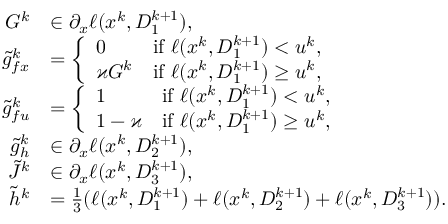<formula> <loc_0><loc_0><loc_500><loc_500>\begin{array} { r l } { G ^ { k } } & { \in \partial _ { x } \ell ( x ^ { k } , D _ { 1 } ^ { k + 1 } ) , } \\ { \tilde { g } _ { f x } ^ { k } } & { = \left \{ \begin{array} { l l } { 0 } & { i f \ell ( x ^ { k } , D _ { 1 } ^ { k + 1 } ) < u ^ { k } , } \\ { \varkappa G ^ { k } } & { i f \ell ( x ^ { k } , D _ { 1 } ^ { k + 1 } ) \geq u ^ { k } , } \end{array} } \\ { \tilde { g } _ { f u } ^ { k } } & { = \left \{ \begin{array} { l l } { 1 } & { i f \ell ( x ^ { k } , D _ { 1 } ^ { k + 1 } ) < u ^ { k } , } \\ { 1 - \varkappa } & { i f \ell ( x ^ { k } , D _ { 1 } ^ { k + 1 } ) \geq u ^ { k } , } \end{array} } \\ { \tilde { g } _ { h } ^ { k } } & { \in \partial _ { x } \ell ( x ^ { k } , D _ { 2 } ^ { k + 1 } ) , } \\ { \tilde { J } ^ { k } } & { \in \partial _ { x } \ell ( x ^ { k } , D _ { 3 } ^ { k + 1 } ) , } \\ { \tilde { h } ^ { k } } & { = \frac { 1 } { 3 } ( \ell ( x ^ { k } , D _ { 1 } ^ { k + 1 } ) + \ell ( x ^ { k } , D _ { 2 } ^ { k + 1 } ) + \ell ( x ^ { k } , D _ { 3 } ^ { k + 1 } ) ) . } \end{array}</formula> 